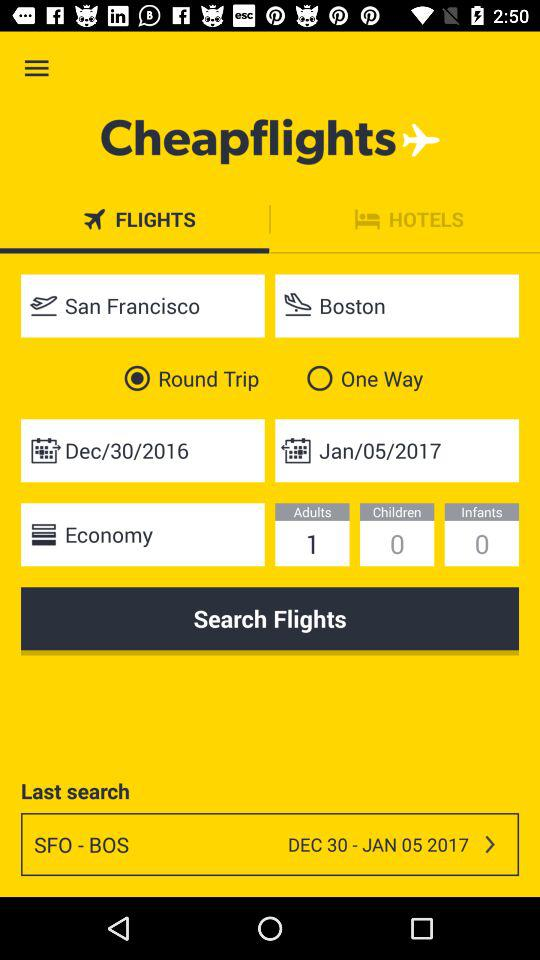What is the departure location? The departure location is San Francisco. 